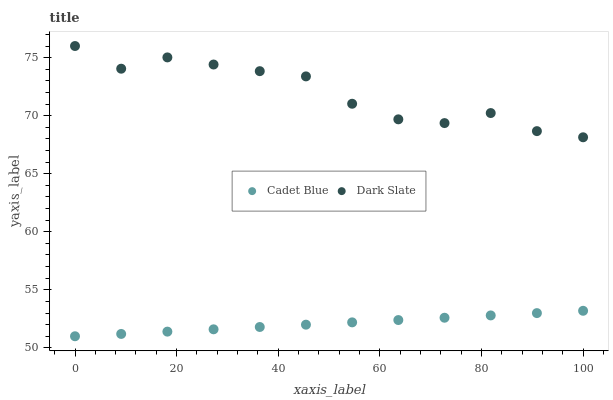Does Cadet Blue have the minimum area under the curve?
Answer yes or no. Yes. Does Dark Slate have the maximum area under the curve?
Answer yes or no. Yes. Does Cadet Blue have the maximum area under the curve?
Answer yes or no. No. Is Cadet Blue the smoothest?
Answer yes or no. Yes. Is Dark Slate the roughest?
Answer yes or no. Yes. Is Cadet Blue the roughest?
Answer yes or no. No. Does Cadet Blue have the lowest value?
Answer yes or no. Yes. Does Dark Slate have the highest value?
Answer yes or no. Yes. Does Cadet Blue have the highest value?
Answer yes or no. No. Is Cadet Blue less than Dark Slate?
Answer yes or no. Yes. Is Dark Slate greater than Cadet Blue?
Answer yes or no. Yes. Does Cadet Blue intersect Dark Slate?
Answer yes or no. No. 